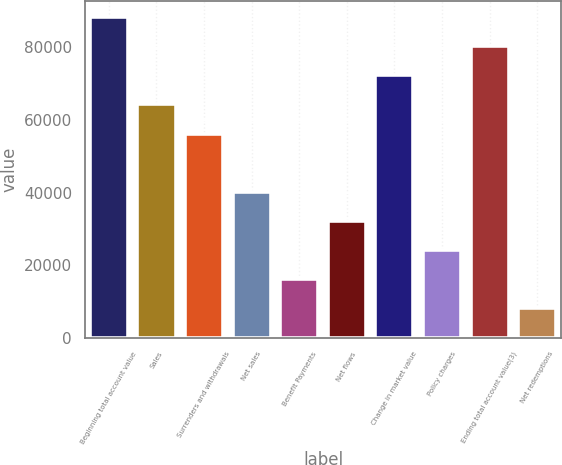<chart> <loc_0><loc_0><loc_500><loc_500><bar_chart><fcel>Beginning total account value<fcel>Sales<fcel>Surrenders and withdrawals<fcel>Net sales<fcel>Benefit Payments<fcel>Net flows<fcel>Change in market value<fcel>Policy charges<fcel>Ending total account value(3)<fcel>Net redemptions<nl><fcel>88350.3<fcel>64289.4<fcel>56269.1<fcel>40228.5<fcel>16167.6<fcel>32208.2<fcel>72309.7<fcel>24187.9<fcel>80330<fcel>8147.3<nl></chart> 